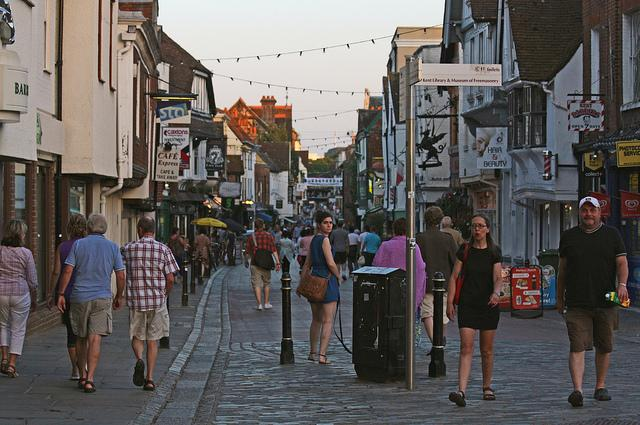What kind of area in town is this? Please explain your reasoning. shopping area. The area is for shopping. 